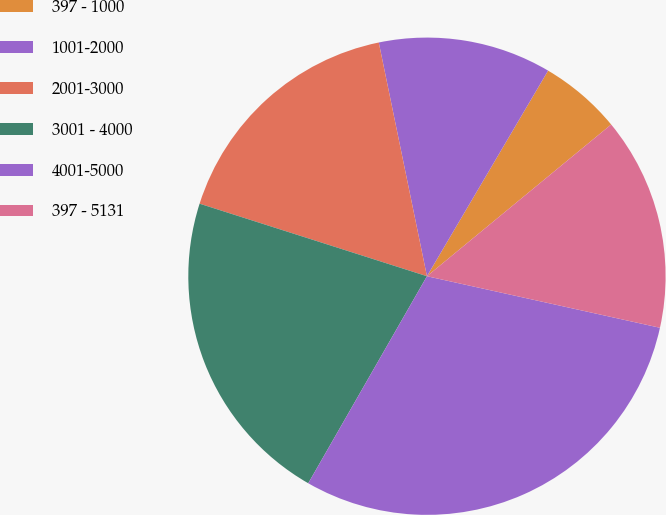<chart> <loc_0><loc_0><loc_500><loc_500><pie_chart><fcel>397 - 1000<fcel>1001-2000<fcel>2001-3000<fcel>3001 - 4000<fcel>4001-5000<fcel>397 - 5131<nl><fcel>5.56%<fcel>11.71%<fcel>16.85%<fcel>21.63%<fcel>29.82%<fcel>14.43%<nl></chart> 